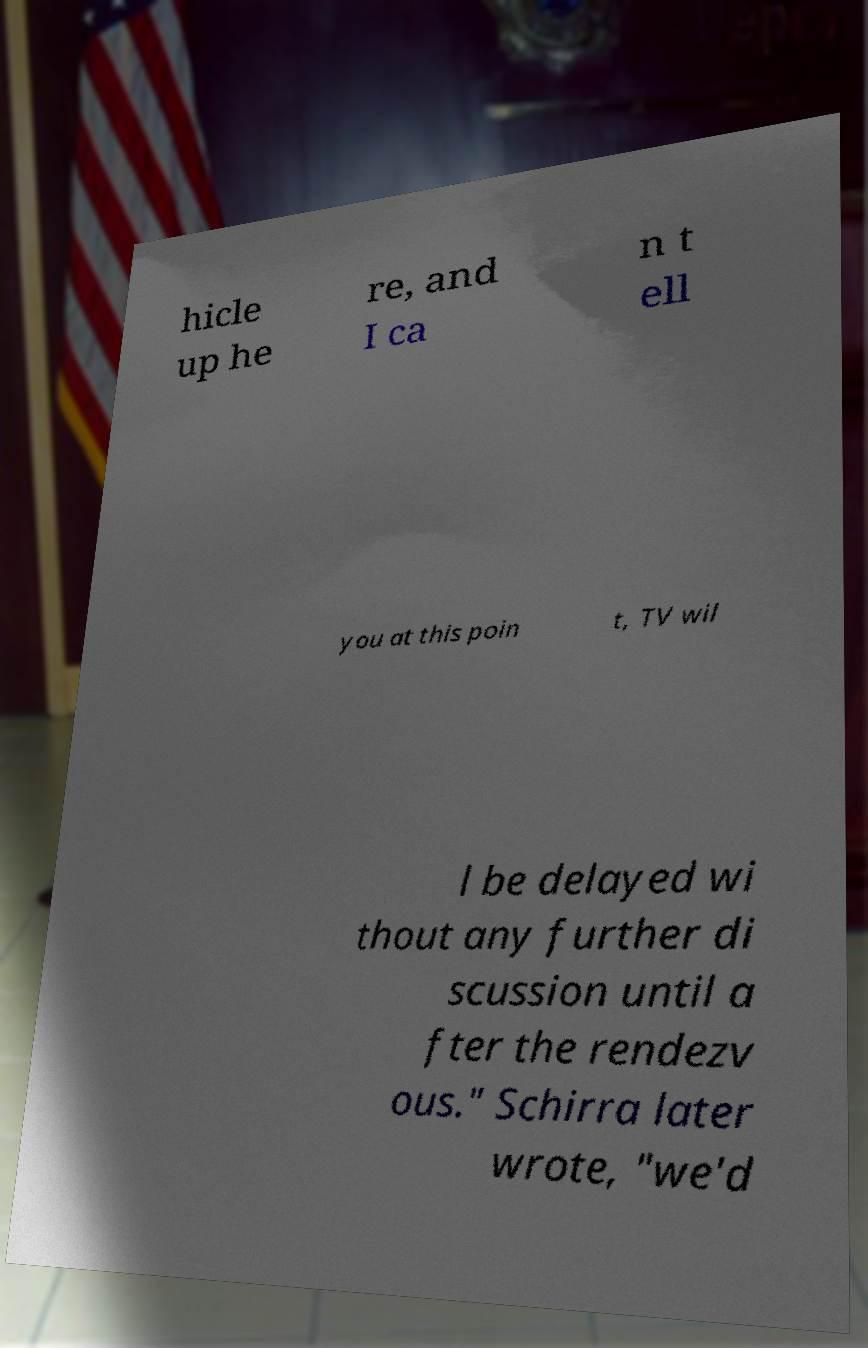Could you assist in decoding the text presented in this image and type it out clearly? hicle up he re, and I ca n t ell you at this poin t, TV wil l be delayed wi thout any further di scussion until a fter the rendezv ous." Schirra later wrote, "we'd 